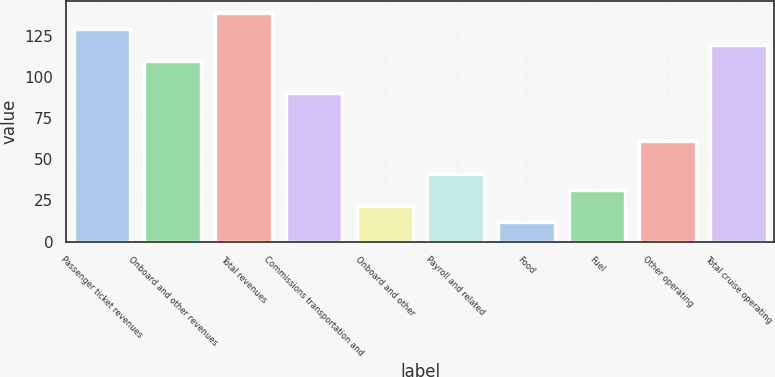Convert chart to OTSL. <chart><loc_0><loc_0><loc_500><loc_500><bar_chart><fcel>Passenger ticket revenues<fcel>Onboard and other revenues<fcel>Total revenues<fcel>Commissions transportation and<fcel>Onboard and other<fcel>Payroll and related<fcel>Food<fcel>Fuel<fcel>Other operating<fcel>Total cruise operating<nl><fcel>129.31<fcel>109.77<fcel>139.08<fcel>90.23<fcel>21.84<fcel>41.38<fcel>12.07<fcel>31.61<fcel>60.92<fcel>119.54<nl></chart> 